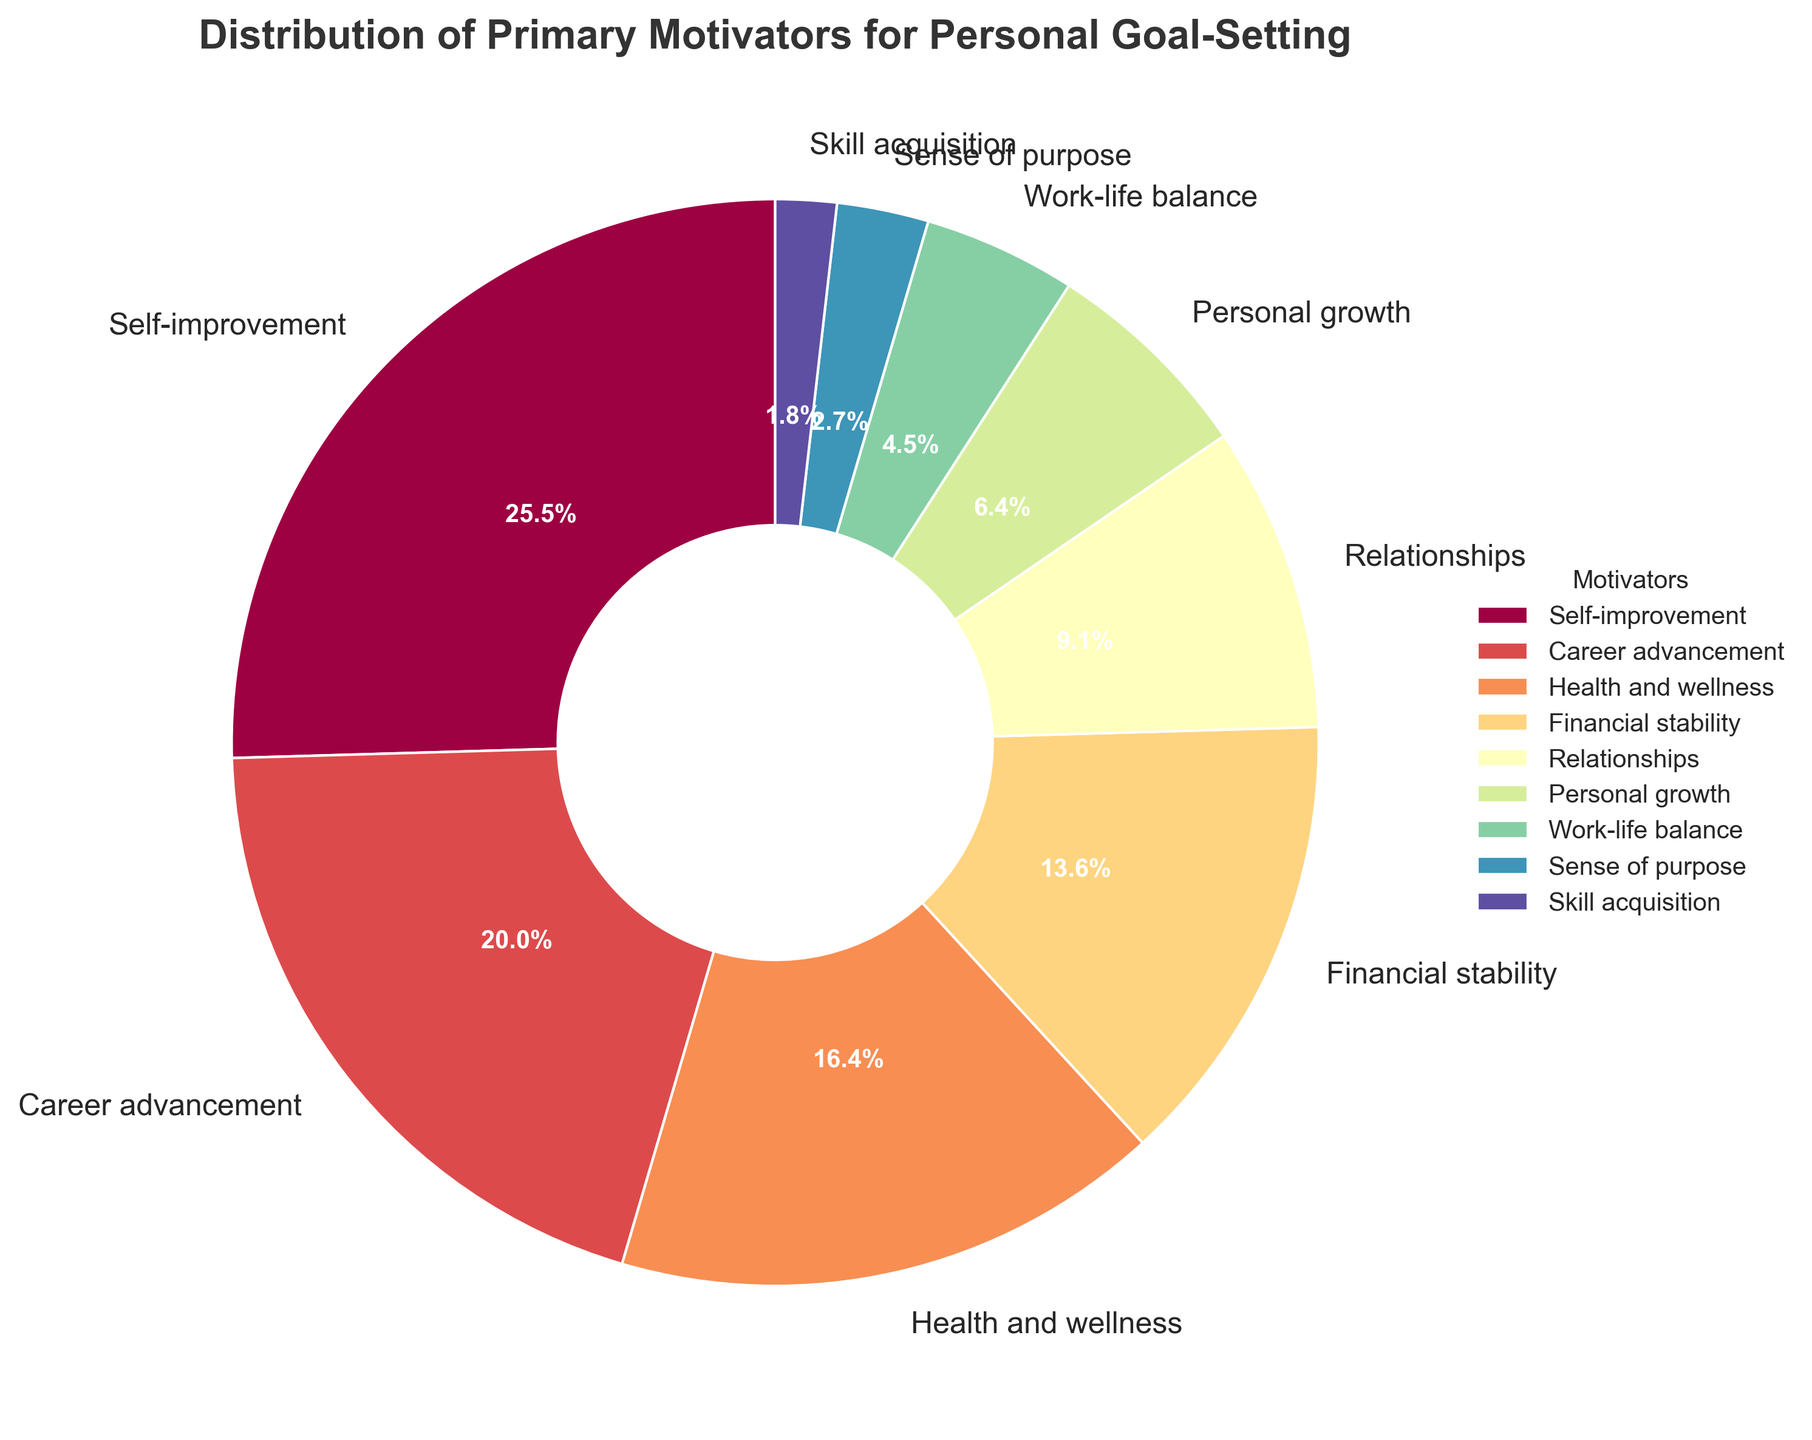What's the most common primary motivator for personal goal-setting? The sector labeled "Self-improvement" is the largest in the pie chart. Therefore, self-improvement is the most common primary motivator.
Answer: Self-improvement What percentage of people are motivated by career advancement? The sector labeled "Career advancement" shows the percentage directly, which is 22%.
Answer: 22% Which motivator has the smallest representation? The smallest sector in the pie chart is labeled "Skill acquisition" with a 2% share. Therefore, skill acquisition has the smallest representation.
Answer: Skill acquisition How does the percentage of individuals motivated by relationships compare to those motivated by health and wellness? The percentage for relationships is 10%, while it is 18% for health and wellness. Clearly, more individuals are motivated by health and wellness compared to relationships.
Answer: Health and wellness has a higher percentage What is the combined percentage of those motivated by financial stability and work-life balance? Financial stability has a percentage of 15%, and work-life balance has a percentage of 5%. Therefore, their combined percentage is 15% + 5% = 20%.
Answer: 20% Is the percentage of individuals aiming for personal growth less than or greater than those seeking a sense of purpose? The percentage of individuals aiming for personal growth is 7%, which is greater than those seeking a sense of purpose, which is 3%.
Answer: Greater than What is the second most common primary motivator for personal goal-setting? The second largest sector in the pie chart corresponds to "Career advancement," which is 22%.
Answer: Career advancement What is the total percentage of people motivated by both self-improvement and career advancement? Self-improvement is 28% and career advancement is 22%. Adding these together gives 28% + 22% = 50%.
Answer: 50% Based on the visual appearance, which sector uses the brightest color? The sector labeled "Self-improvement" appears to use the brightest and most prominent color in the pie chart.
Answer: Self-improvement How does the percentage for health and wellness compare to the sum of those motivated by relationships and skill acquisition? Health and wellness is 18%. Relationships and skill acquisition together are 10% + 2% = 12%. Therefore, health and wellness is greater than the sum of relationships and skill acquisition.
Answer: Greater than 